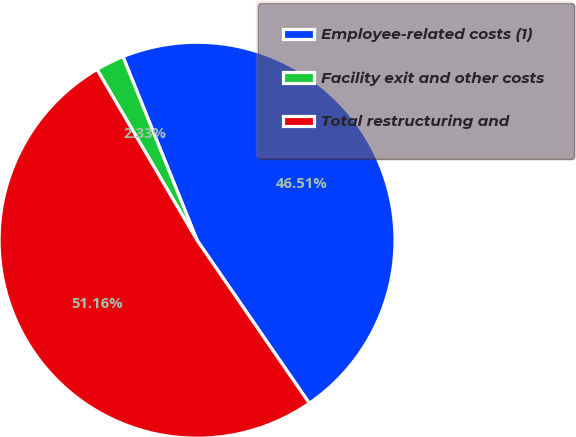Convert chart. <chart><loc_0><loc_0><loc_500><loc_500><pie_chart><fcel>Employee-related costs (1)<fcel>Facility exit and other costs<fcel>Total restructuring and<nl><fcel>46.51%<fcel>2.33%<fcel>51.16%<nl></chart> 